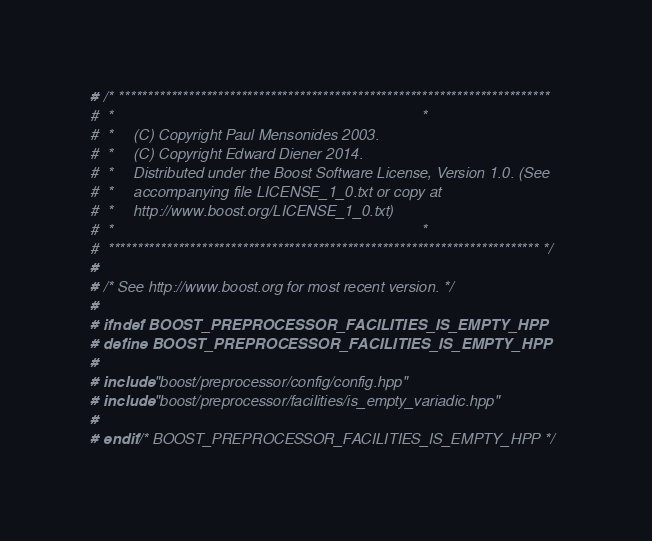<code> <loc_0><loc_0><loc_500><loc_500><_C++_># /* **************************************************************************
#  *                                                                          *
#  *     (C) Copyright Paul Mensonides 2003.
#  *     (C) Copyright Edward Diener 2014.
#  *     Distributed under the Boost Software License, Version 1.0. (See
#  *     accompanying file LICENSE_1_0.txt or copy at
#  *     http://www.boost.org/LICENSE_1_0.txt)
#  *                                                                          *
#  ************************************************************************** */
#
# /* See http://www.boost.org for most recent version. */
#
# ifndef BOOST_PREPROCESSOR_FACILITIES_IS_EMPTY_HPP
# define BOOST_PREPROCESSOR_FACILITIES_IS_EMPTY_HPP
#
# include "boost/preprocessor/config/config.hpp"
# include "boost/preprocessor/facilities/is_empty_variadic.hpp"
#
# endif /* BOOST_PREPROCESSOR_FACILITIES_IS_EMPTY_HPP */
</code> 